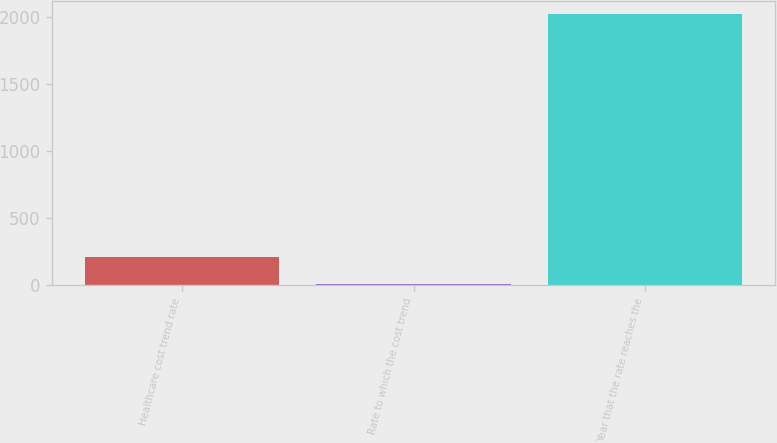Convert chart. <chart><loc_0><loc_0><loc_500><loc_500><bar_chart><fcel>Healthcare cost trend rate<fcel>Rate to which the cost trend<fcel>Year that the rate reaches the<nl><fcel>205.95<fcel>4.5<fcel>2019<nl></chart> 